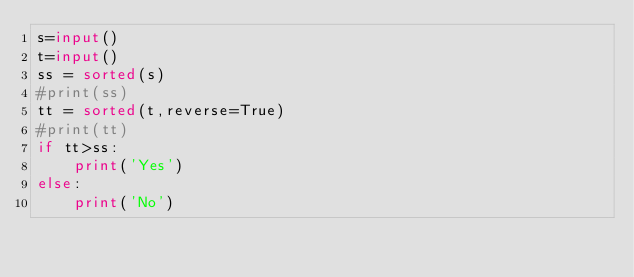Convert code to text. <code><loc_0><loc_0><loc_500><loc_500><_Python_>s=input()
t=input()
ss = sorted(s)
#print(ss)
tt = sorted(t,reverse=True)
#print(tt)
if tt>ss:
    print('Yes')
else:
    print('No')
</code> 